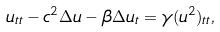<formula> <loc_0><loc_0><loc_500><loc_500>u _ { t t } - c ^ { 2 } \Delta u - \beta \Delta u _ { t } & = \gamma ( u ^ { 2 } ) _ { t t } ,</formula> 